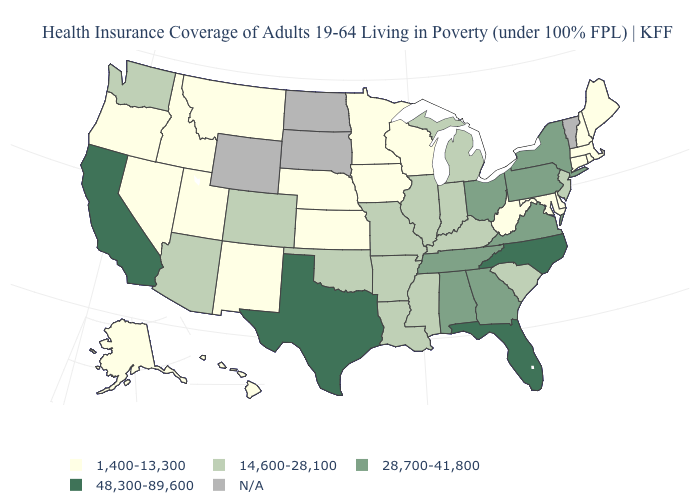What is the value of Washington?
Concise answer only. 14,600-28,100. Which states hav the highest value in the MidWest?
Quick response, please. Ohio. What is the value of Florida?
Concise answer only. 48,300-89,600. What is the lowest value in the USA?
Keep it brief. 1,400-13,300. Which states hav the highest value in the West?
Short answer required. California. What is the lowest value in the USA?
Short answer required. 1,400-13,300. What is the value of Minnesota?
Give a very brief answer. 1,400-13,300. What is the value of Vermont?
Concise answer only. N/A. What is the highest value in the MidWest ?
Short answer required. 28,700-41,800. What is the value of New Jersey?
Answer briefly. 14,600-28,100. Name the states that have a value in the range 48,300-89,600?
Be succinct. California, Florida, North Carolina, Texas. How many symbols are there in the legend?
Answer briefly. 5. What is the highest value in the MidWest ?
Short answer required. 28,700-41,800. Name the states that have a value in the range 14,600-28,100?
Concise answer only. Arizona, Arkansas, Colorado, Illinois, Indiana, Kentucky, Louisiana, Michigan, Mississippi, Missouri, New Jersey, Oklahoma, South Carolina, Washington. Name the states that have a value in the range 14,600-28,100?
Write a very short answer. Arizona, Arkansas, Colorado, Illinois, Indiana, Kentucky, Louisiana, Michigan, Mississippi, Missouri, New Jersey, Oklahoma, South Carolina, Washington. 